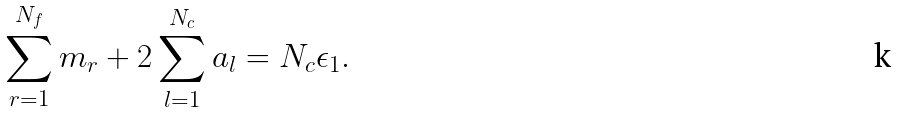Convert formula to latex. <formula><loc_0><loc_0><loc_500><loc_500>\sum _ { r = 1 } ^ { N _ { f } } m _ { r } + 2 \sum _ { l = 1 } ^ { N _ { c } } a _ { l } = N _ { c } \epsilon _ { 1 } .</formula> 